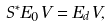<formula> <loc_0><loc_0><loc_500><loc_500>S ^ { * } E _ { 0 } V = E _ { d } V ,</formula> 